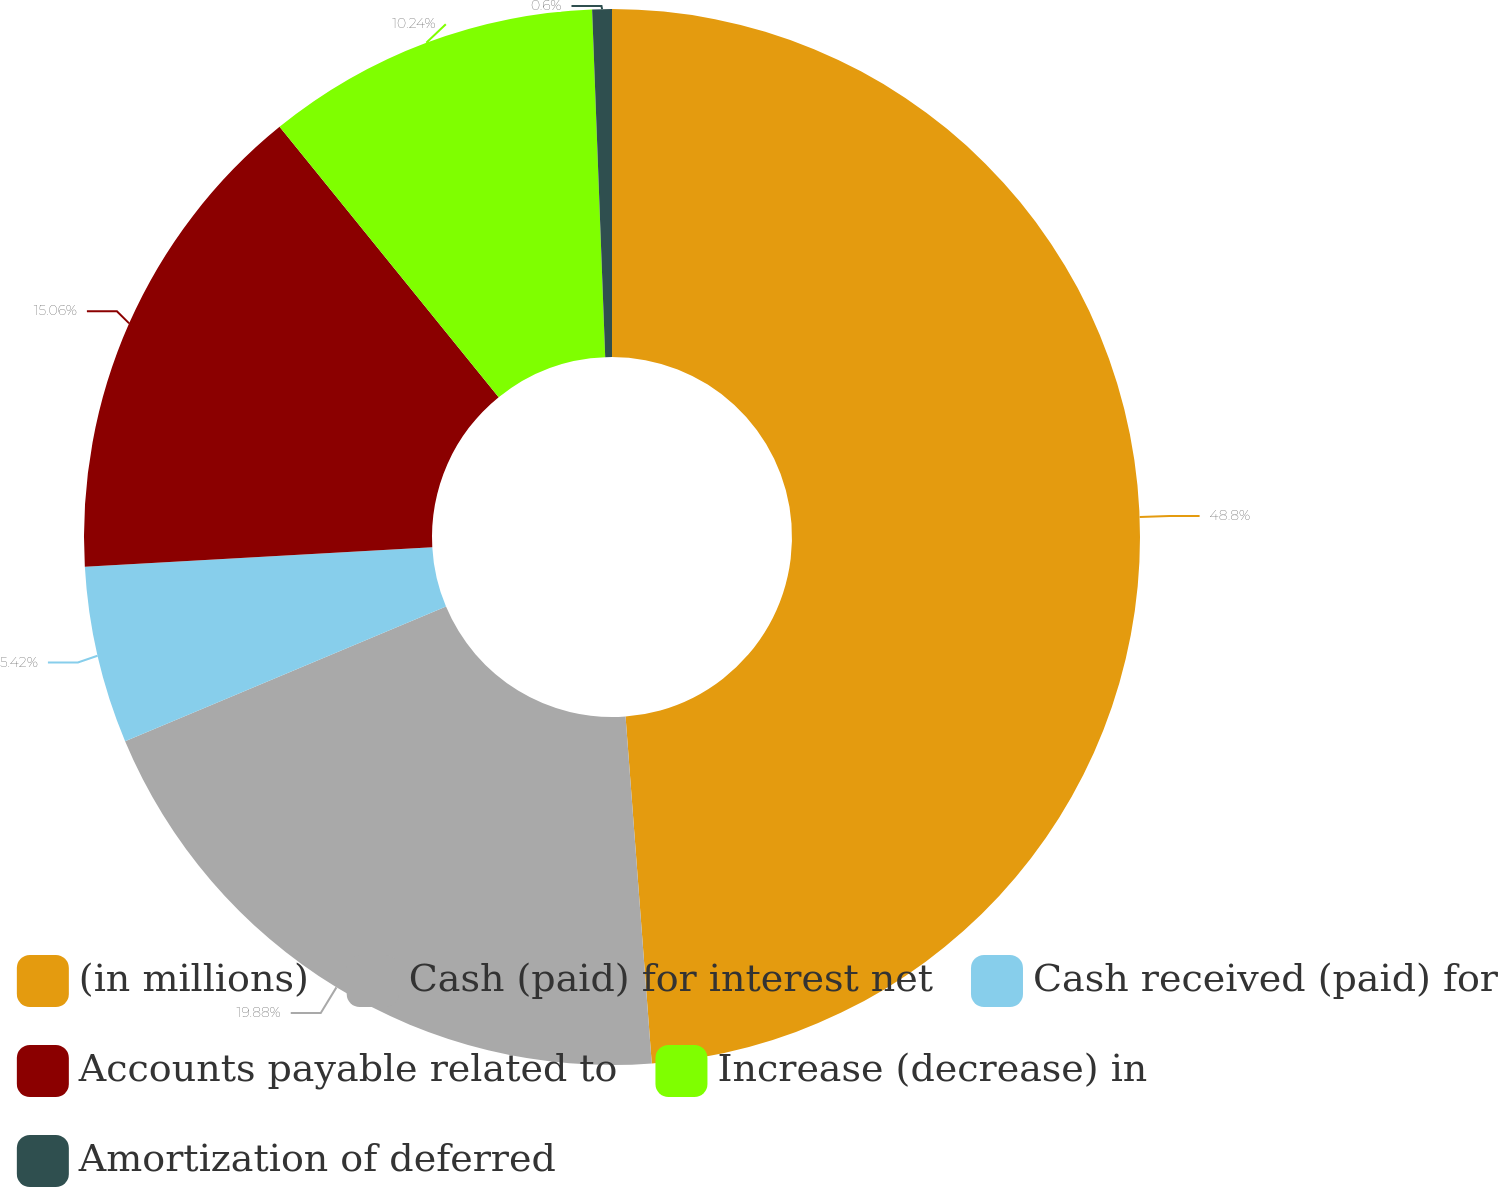<chart> <loc_0><loc_0><loc_500><loc_500><pie_chart><fcel>(in millions)<fcel>Cash (paid) for interest net<fcel>Cash received (paid) for<fcel>Accounts payable related to<fcel>Increase (decrease) in<fcel>Amortization of deferred<nl><fcel>48.8%<fcel>19.88%<fcel>5.42%<fcel>15.06%<fcel>10.24%<fcel>0.6%<nl></chart> 